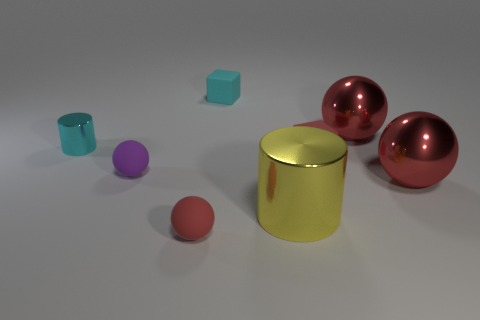Are there an equal number of large purple metallic blocks and small matte blocks? No, there are not an equal number. Upon examining the image, we can observe that there are two large purple metallic spheres and only one small matte teal cube. Therefore, the number of large purple metallic objects does not equal the number of small matte objects. 